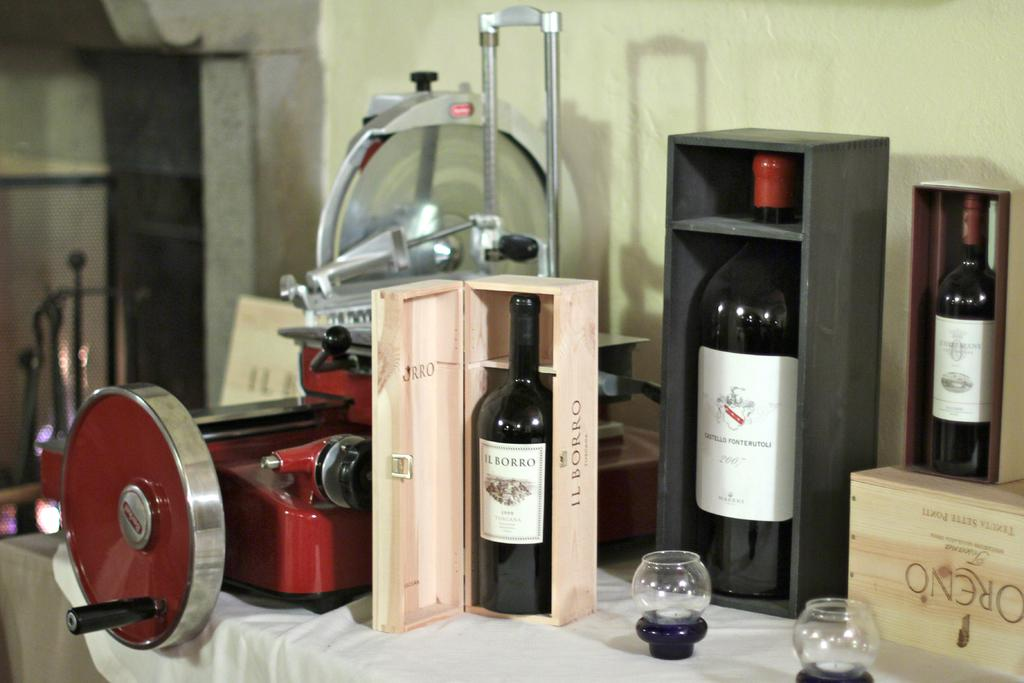<image>
Describe the image concisely. A bottle of Il Borro wine is shown in a wooden box. 